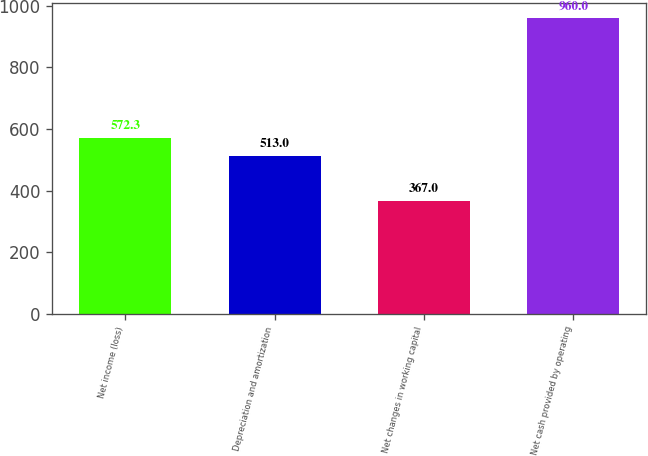<chart> <loc_0><loc_0><loc_500><loc_500><bar_chart><fcel>Net income (loss)<fcel>Depreciation and amortization<fcel>Net changes in working capital<fcel>Net cash provided by operating<nl><fcel>572.3<fcel>513<fcel>367<fcel>960<nl></chart> 